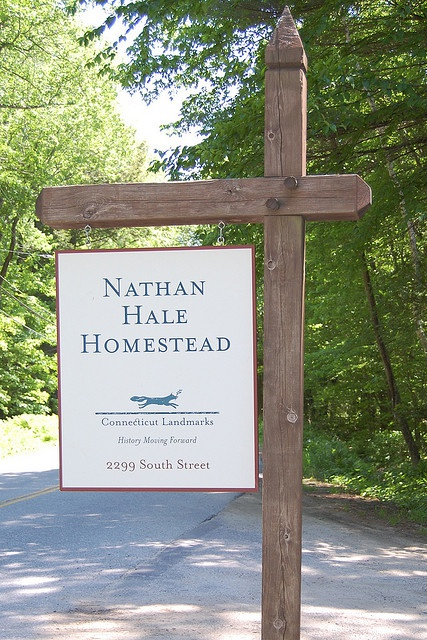Describe the objects in this image and their specific colors. I can see various objects in this image with different colors. 